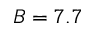<formula> <loc_0><loc_0><loc_500><loc_500>B = 7 . 7</formula> 